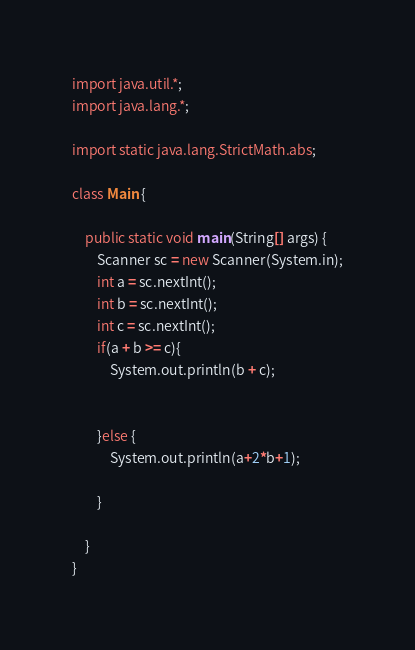<code> <loc_0><loc_0><loc_500><loc_500><_Java_>import java.util.*;
import java.lang.*;

import static java.lang.StrictMath.abs;

class Main {

    public static void main(String[] args) {
        Scanner sc = new Scanner(System.in);
        int a = sc.nextInt();
        int b = sc.nextInt();
        int c = sc.nextInt();
        if(a + b >= c){
            System.out.println(b + c);


        }else {
            System.out.println(a+2*b+1);

        }

    }
}
</code> 